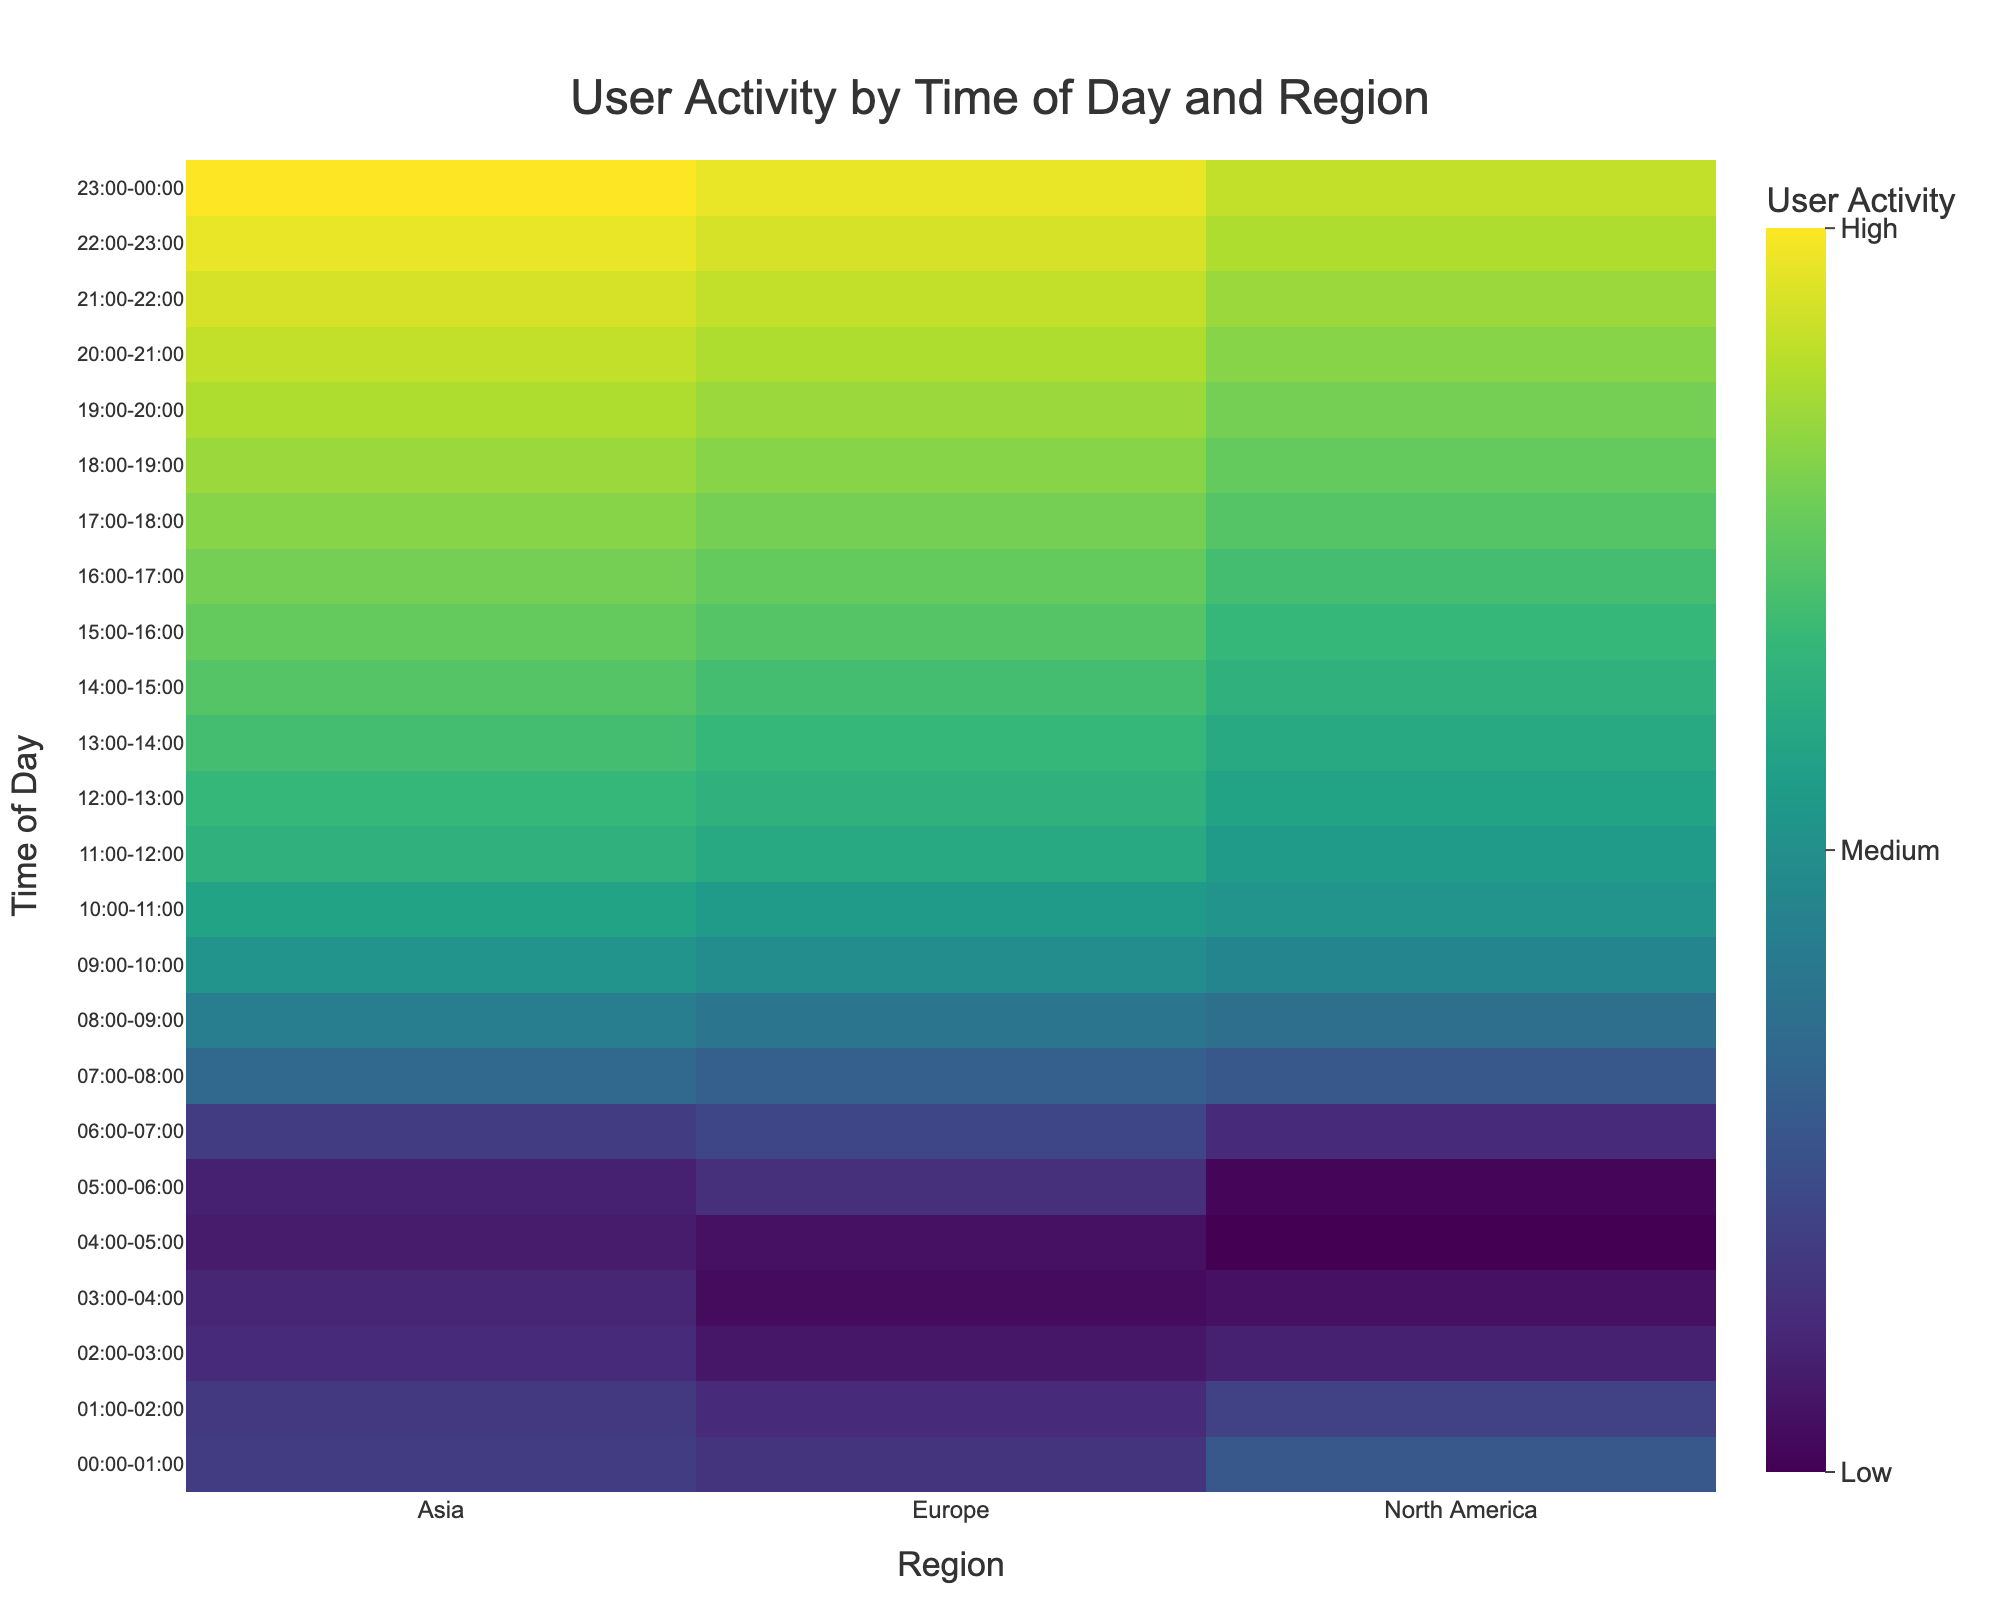What is the highest user activity value, and at what time and region does it occur? The highest user activity value is seen where the color is brightest on the heatmap (closer to yellow in the Viridis scale). Locate the time from the y-axis and the region from the x-axis corresponding to this bright area.
Answer: 23:00-00:00, Asia What is the overall trend of user activity as the day progresses? Observe the color gradient from the top of the heatmap to the bottom. Notice how the colors transition from darker to brighter tones as time progresses, indicating increased user activity.
Answer: Increasing Which region has the lowest user activity during the early hours (00:00-04:00)? Focus on the earliest times on the y-axis (00:00-04:00) and compare the colors for different regions. The darker color represents lower values, indicating Europe has consistently darker colors in this time frame.
Answer: Europe What is the difference in user activity between the hours of 08:00-09:00 and 20:00-21:00 for North America? Identify the colors at 08:00-09:00 and 20:00-21:00 for North America and find the corresponding user activity values from the dataset. The values are 150 and 300 respectively. The difference is therefore 300 - 150.
Answer: 150 How does user activity in Asia during 12:00-13:00 compare to Europe during the same period? Look for the colors at 12:00-13:00 in Asia and Europe and note their respective user activity values from the dataset. Asia has 250, and Europe has 240. Comparing these values, Asia has a higher activity count.
Answer: Asia has higher activity What's the median user activity value for Europe between 10:00 and 16:00? List the user activity values for Europe between 10:00 and 16:00: [210, 230, 240, 250, 260, 270, 280]. Since there are 7 values, the median is the middle value in the ordered list, which is 250.
Answer: 250 In which time slot does North America exhibit the lowest user activity? Scan the heatmap for North America (x-axis) and identify the darkest color, corresponding to the lowest user activity value. This occurs from 04:00-05:00 with an activity value of 30.
Answer: 04:00-05:00 Is there any time slot where user activity in all regions is equal? Check the heatmap and compare the colors across all regions for each time slot. Differences in shades indicate that there is no time slot where user activities are equal for all regions.
Answer: No What are the user activity trends in Europe from midnight to noon? From the top to the middle of the heatmap on the Europe column, observe the color changes from darker to lighter tones, indicating an initial low activity that progressively rises towards noon.
Answer: Increasing How does user activity in North America at 15:00-16:00 compare to Asia at the same time? Note the color and corresponding activity values on the heatmap from 15:00-16:00 for both North America and Asia. North America has a value of 250, and Asia has 280. Therefore, Asia has higher user activity during this period.
Answer: Asia has higher activity 